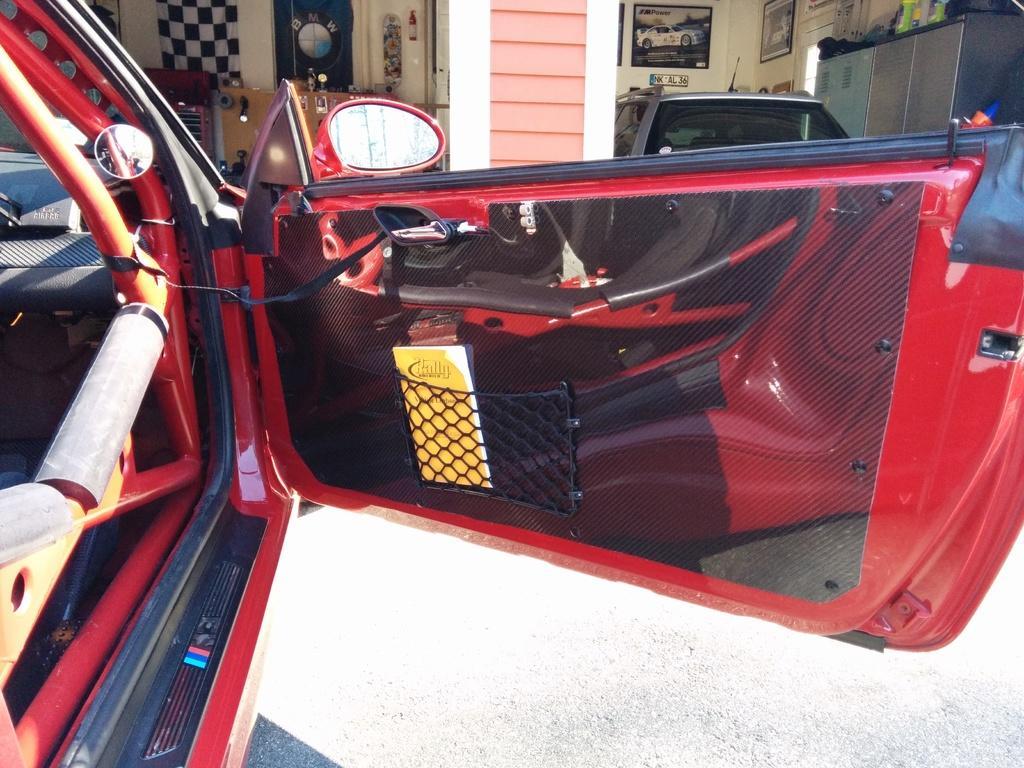Please provide a concise description of this image. In this picture I can see two cars in the middle, at the top there are photo frames on the wall. 